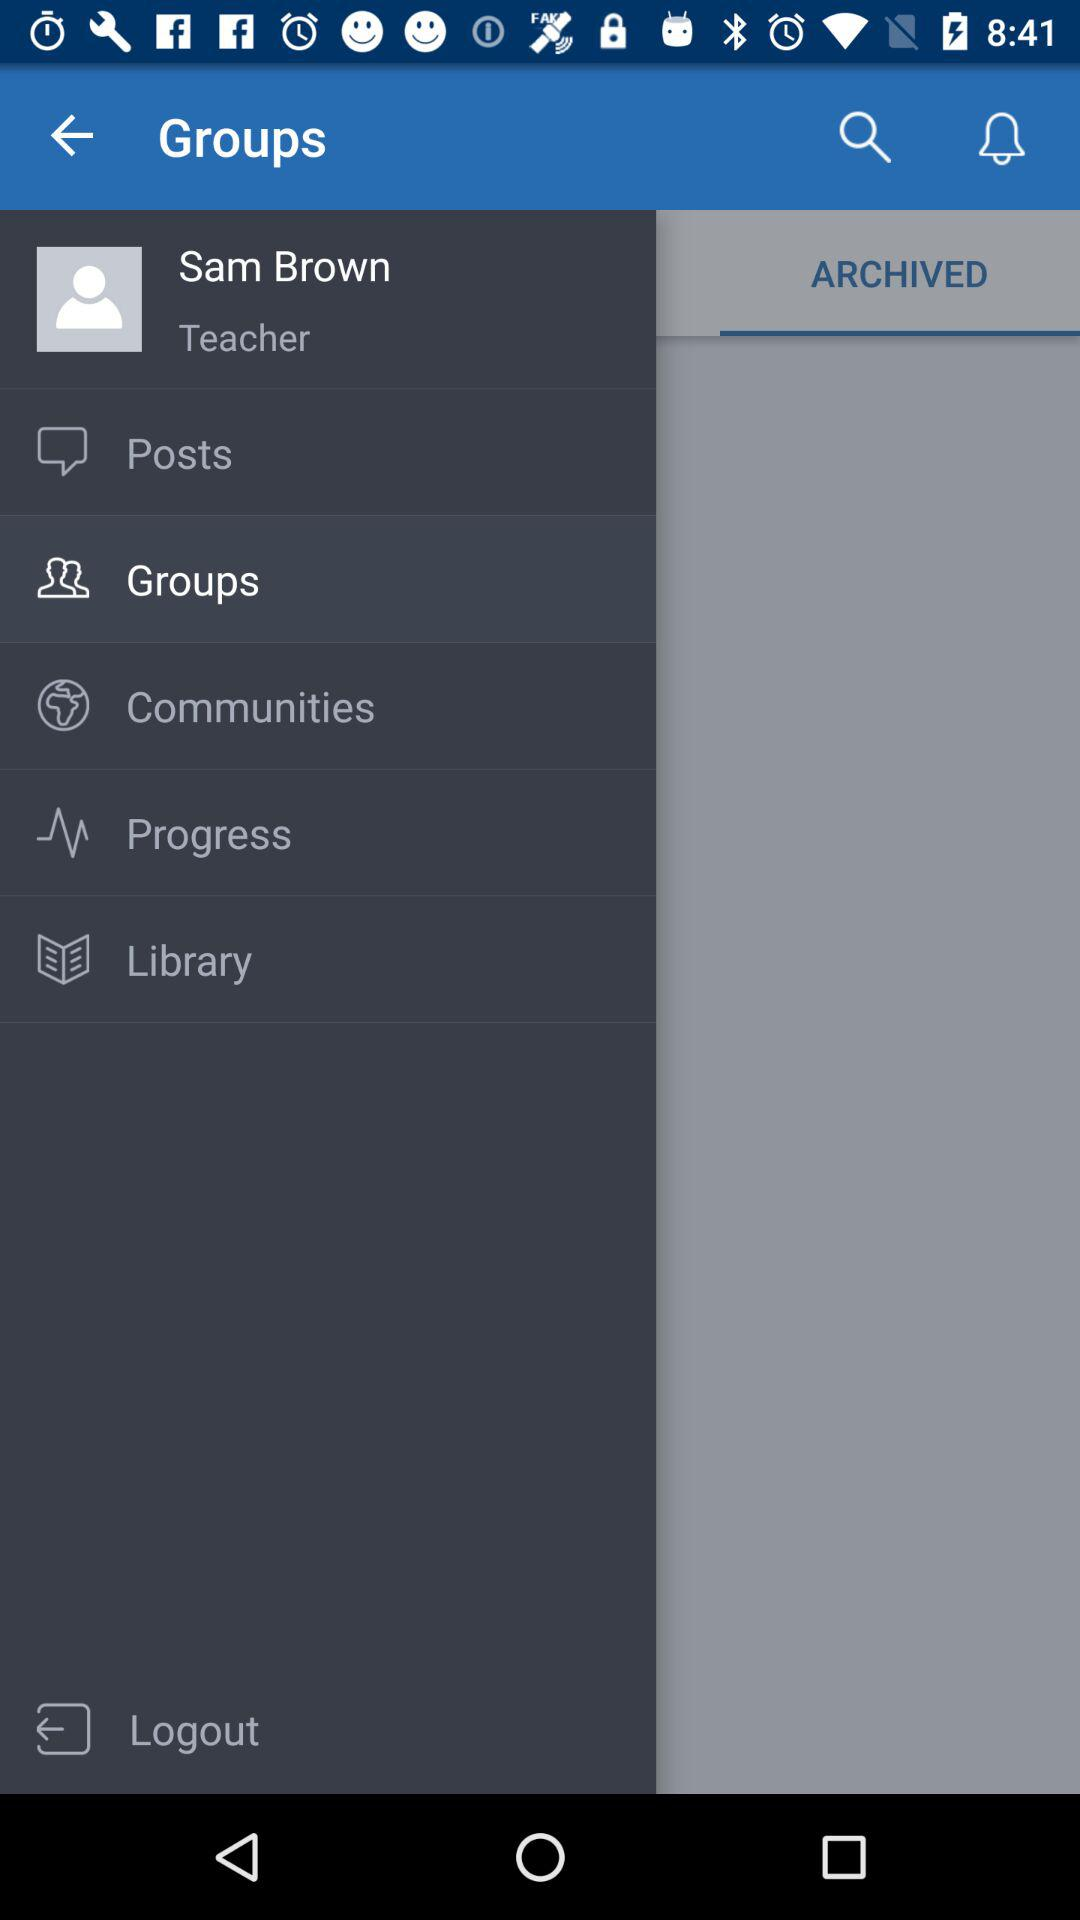What is the user name? The user name is Sam Brown. 